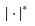Convert formula to latex. <formula><loc_0><loc_0><loc_500><loc_500>| \cdot | ^ { * }</formula> 